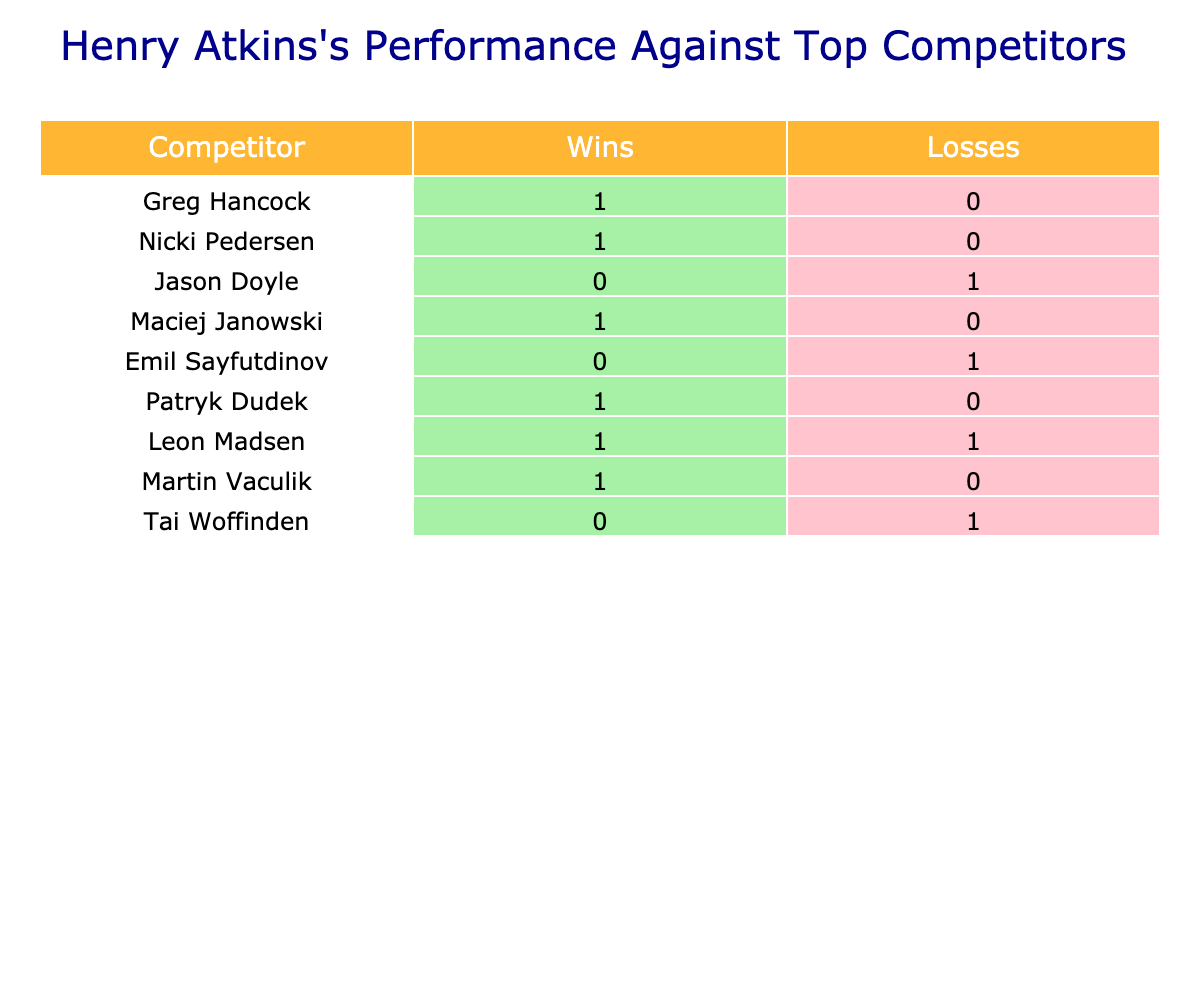What is the total number of wins Henry Atkins had against Greg Hancock? The table shows a win of 1 against Greg Hancock. This is directly stated in the row corresponding to this competitor.
Answer: 1 How many losses did Henry Atkins have against Tai Woffinden? The table indicates a loss of 1 against Tai Woffinden. This is also stated directly in the table.
Answer: 1 Who was the only competitor Henry Atkins lost to? By scanning through the table, we see that he lost to Jason Doyle and Emil Sayfutdinov, as both have a loss of 1. Thus, there are two competitors he lost to.
Answer: Jason Doyle and Emil Sayfutdinov What is the total number of wins Henry Atkins had against all competitors? To find the total wins, we sum up all wins from the table: 1 (Greg Hancock) + 1 (Nicki Pedersen) + 0 (Jason Doyle) + 1 (Maciej Janowski) + 0 (Emil Sayfutdinov) + 1 (Patryk Dudek) + 1 (Leon Madsen) + 1 (Martin Vaculik) + 0 (Tai Woffinden) = 6.
Answer: 6 Did Henry Atkins have more wins than losses overall? To verify this, we need to calculate total wins (6 as calculated above) and total losses. The total losses can be summed: 0 (Greg Hancock) + 0 (Nicki Pedersen) + 1 (Jason Doyle) + 0 (Maciej Janowski) + 1 (Emil Sayfutdinov) + 0 (Patryk Dudek) + 1 (Leon Madsen) + 0 (Martin Vaculik) + 1 (Tai Woffinden) = 3. Since 6 > 3, he had more wins.
Answer: Yes Which competitor had the highest number of wins against Henry Atkins? Looking at the table, we see that both Jason Doyle and Emil Sayfutdinov are the only competitors that won against Henry Atkins with 1 win each. Since they both show one win, there's no distinct competitor with the highest wins.
Answer: Jason Doyle and Emil Sayfutdinov 